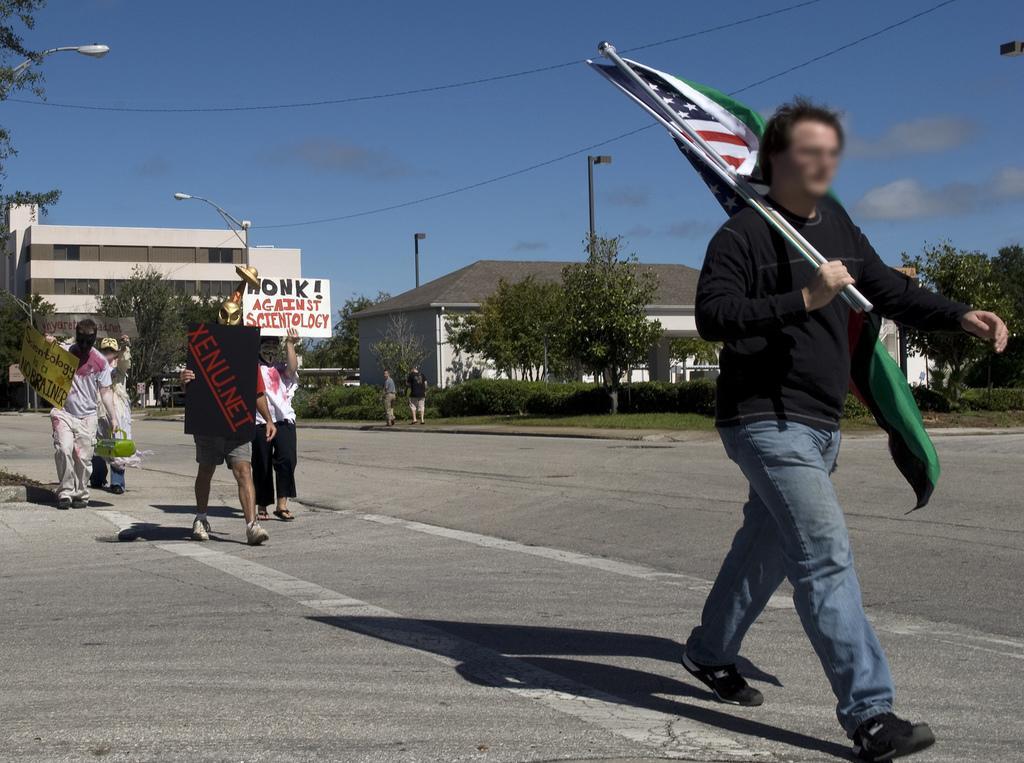In one or two sentences, can you explain what this image depicts? This image consists of few people walking on the road along with the flags and placards. At the bottom, there is a road. In the background, we can trees and buildings along with poles. At the top, there is sky. 